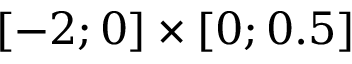Convert formula to latex. <formula><loc_0><loc_0><loc_500><loc_500>[ - 2 ; 0 ] \times [ 0 ; 0 . 5 ]</formula> 